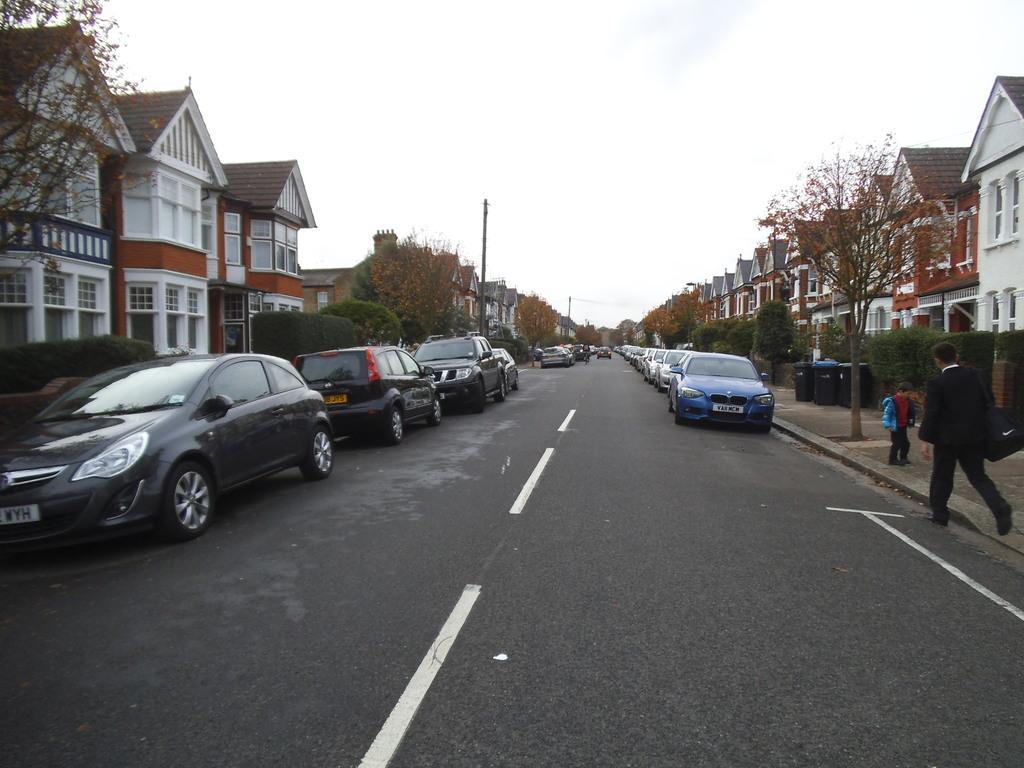Please provide a concise description of this image. In the center of the image there are cars on the road. On the right side of the image there are two people. Behind them there are dustbins. On both right and left side of the image there are trees, buildings. On the left side of the image there are street lights. At the top of the image there is sky. 